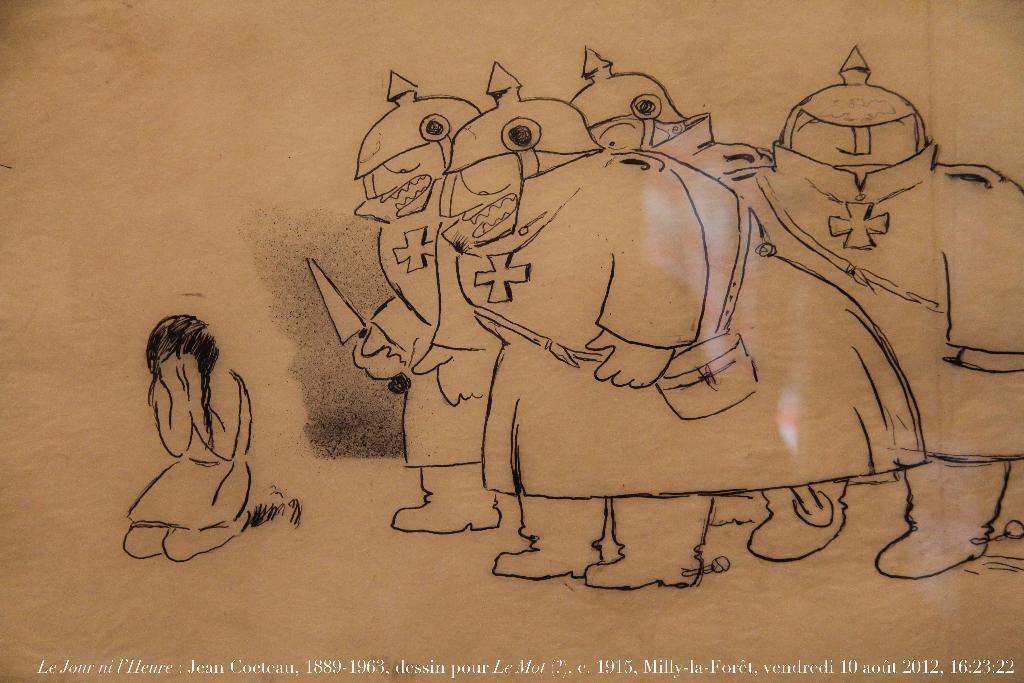Could you give a brief overview of what you see in this image? In the image there is a girl kneeling and crying, beside her there are few soldiers with swords standing. 